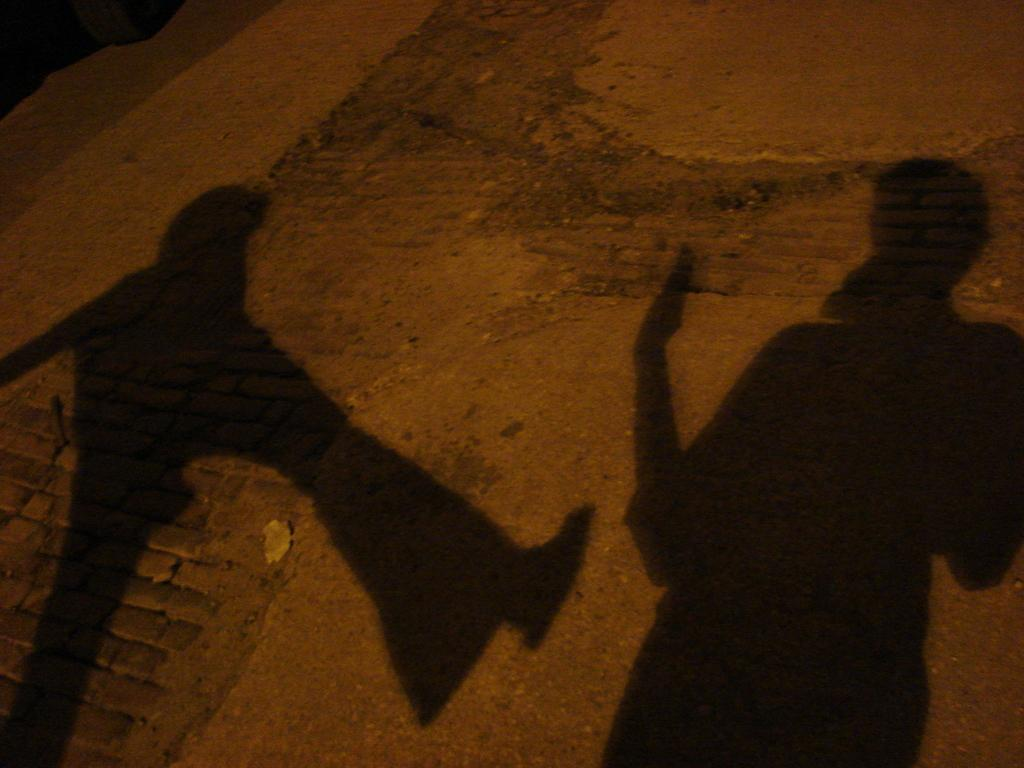What can be seen on the ground in the image? There are shadows of two persons in the image. Where are the shadows located? The shadows are on the ground. What type of jam is being spread on the neck of the person in the image? There is no jam or person present in the image; it only shows shadows of two persons on the ground. 